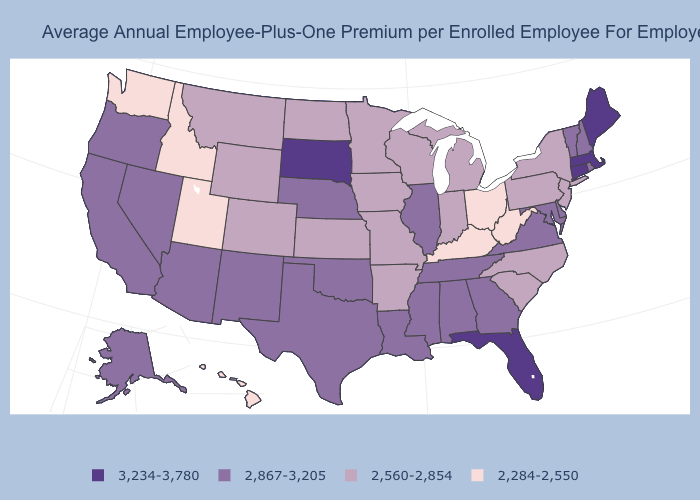Among the states that border West Virginia , which have the lowest value?
Keep it brief. Kentucky, Ohio. Which states have the highest value in the USA?
Give a very brief answer. Connecticut, Florida, Maine, Massachusetts, South Dakota. Does the first symbol in the legend represent the smallest category?
Give a very brief answer. No. Among the states that border New Mexico , does Colorado have the lowest value?
Short answer required. No. Which states hav the highest value in the MidWest?
Concise answer only. South Dakota. Does South Dakota have the highest value in the USA?
Answer briefly. Yes. What is the value of North Carolina?
Short answer required. 2,560-2,854. Name the states that have a value in the range 2,284-2,550?
Give a very brief answer. Hawaii, Idaho, Kentucky, Ohio, Utah, Washington, West Virginia. What is the value of Wisconsin?
Concise answer only. 2,560-2,854. What is the value of Utah?
Quick response, please. 2,284-2,550. What is the lowest value in the South?
Be succinct. 2,284-2,550. Name the states that have a value in the range 2,284-2,550?
Give a very brief answer. Hawaii, Idaho, Kentucky, Ohio, Utah, Washington, West Virginia. Name the states that have a value in the range 3,234-3,780?
Quick response, please. Connecticut, Florida, Maine, Massachusetts, South Dakota. Which states have the highest value in the USA?
Be succinct. Connecticut, Florida, Maine, Massachusetts, South Dakota. Which states have the highest value in the USA?
Short answer required. Connecticut, Florida, Maine, Massachusetts, South Dakota. 